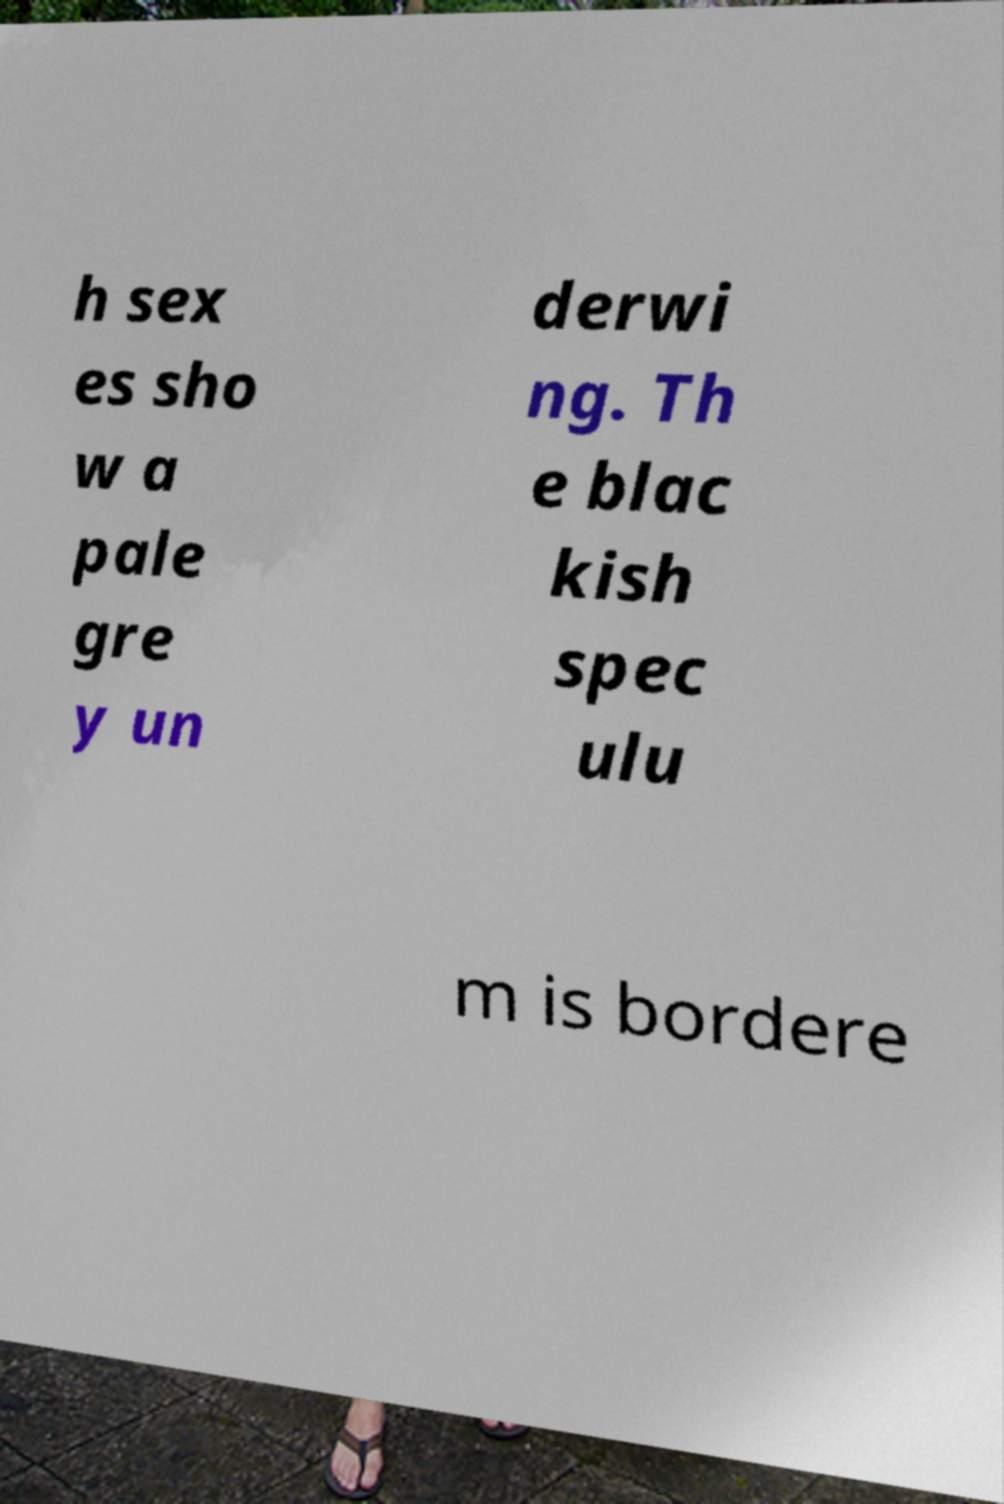Please identify and transcribe the text found in this image. h sex es sho w a pale gre y un derwi ng. Th e blac kish spec ulu m is bordere 